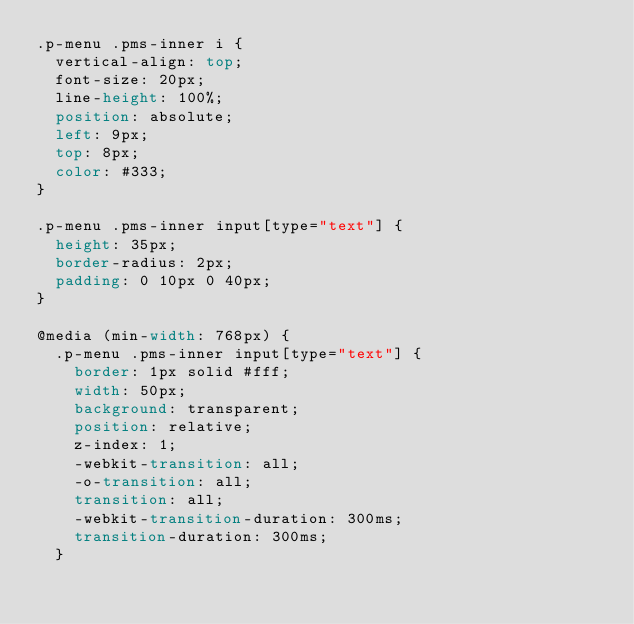<code> <loc_0><loc_0><loc_500><loc_500><_CSS_>.p-menu .pms-inner i {
  vertical-align: top;
  font-size: 20px;
  line-height: 100%;
  position: absolute;
  left: 9px;
  top: 8px;
  color: #333;
}

.p-menu .pms-inner input[type="text"] {
  height: 35px;
  border-radius: 2px;
  padding: 0 10px 0 40px;
}

@media (min-width: 768px) {
  .p-menu .pms-inner input[type="text"] {
    border: 1px solid #fff;
    width: 50px;
    background: transparent;
    position: relative;
    z-index: 1;
    -webkit-transition: all;
    -o-transition: all;
    transition: all;
    -webkit-transition-duration: 300ms;
    transition-duration: 300ms;
  }
</code> 